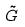Convert formula to latex. <formula><loc_0><loc_0><loc_500><loc_500>\tilde { G }</formula> 